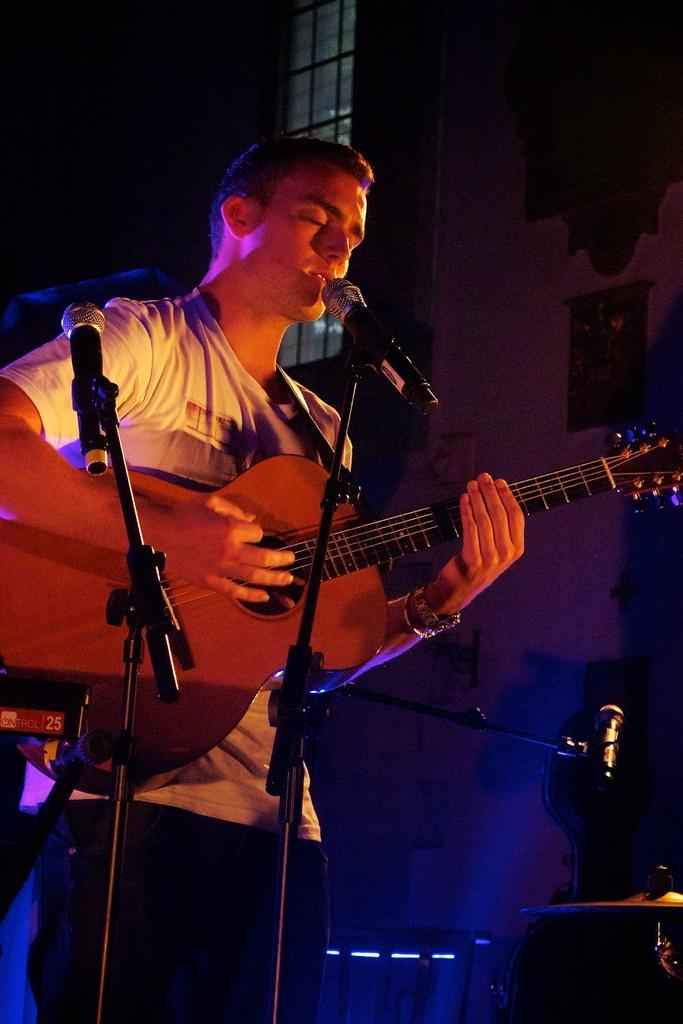What is the main subject of the image? The main subject of the image is a man. What is the man doing in the image? The man is standing in front of a microphone. What musical instrument is the man playing in the image? The man is playing a guitar. How many boys are present in the image? There is no mention of boys in the image; it features a man playing a guitar. What type of beast can be seen in the image? There is no beast present in the image. 